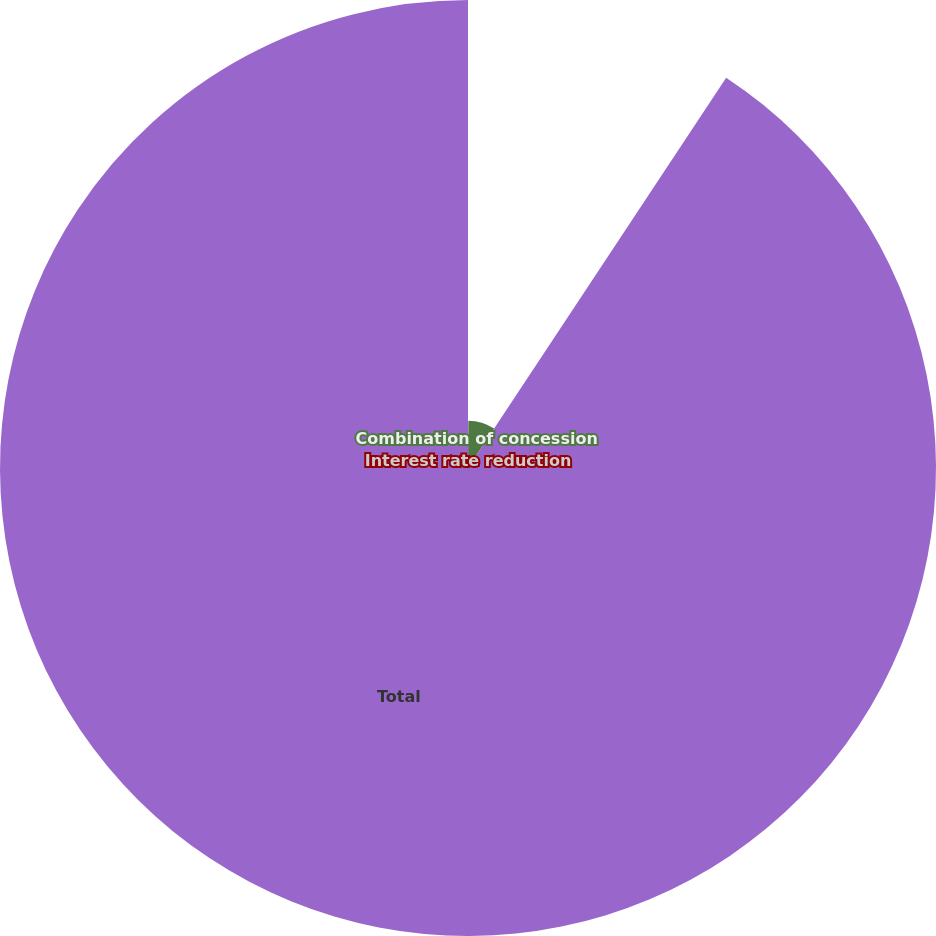Convert chart. <chart><loc_0><loc_0><loc_500><loc_500><pie_chart><fcel>Interest rate reduction<fcel>Combination of concession<fcel>Total<nl><fcel>0.12%<fcel>9.18%<fcel>90.7%<nl></chart> 